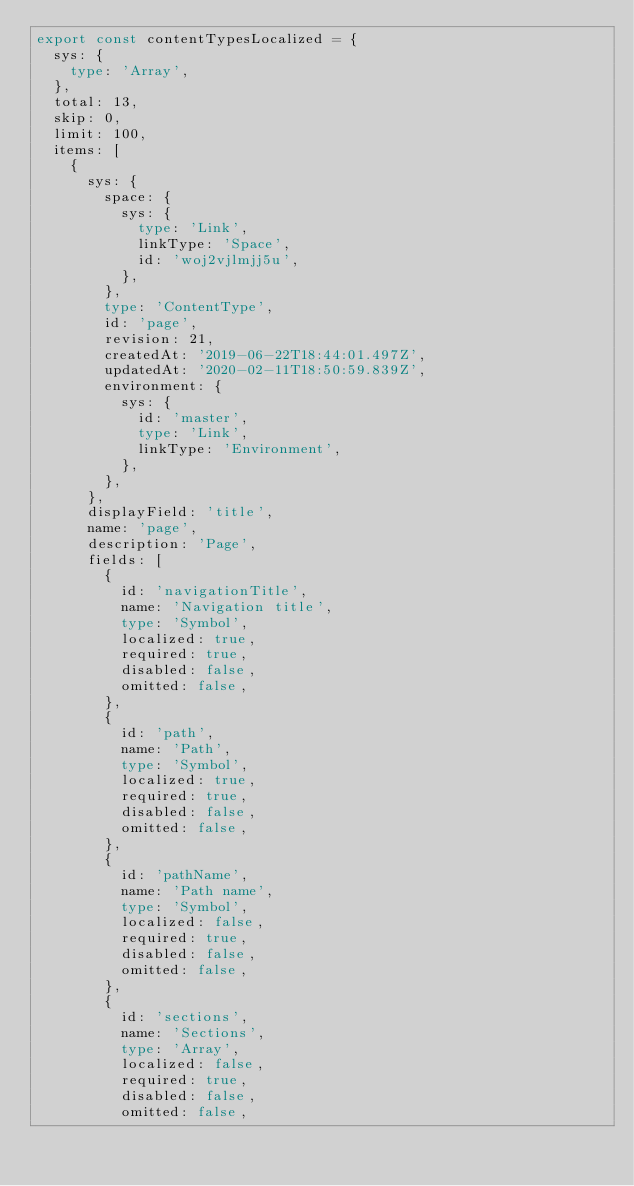Convert code to text. <code><loc_0><loc_0><loc_500><loc_500><_TypeScript_>export const contentTypesLocalized = {
  sys: {
    type: 'Array',
  },
  total: 13,
  skip: 0,
  limit: 100,
  items: [
    {
      sys: {
        space: {
          sys: {
            type: 'Link',
            linkType: 'Space',
            id: 'woj2vjlmjj5u',
          },
        },
        type: 'ContentType',
        id: 'page',
        revision: 21,
        createdAt: '2019-06-22T18:44:01.497Z',
        updatedAt: '2020-02-11T18:50:59.839Z',
        environment: {
          sys: {
            id: 'master',
            type: 'Link',
            linkType: 'Environment',
          },
        },
      },
      displayField: 'title',
      name: 'page',
      description: 'Page',
      fields: [
        {
          id: 'navigationTitle',
          name: 'Navigation title',
          type: 'Symbol',
          localized: true,
          required: true,
          disabled: false,
          omitted: false,
        },
        {
          id: 'path',
          name: 'Path',
          type: 'Symbol',
          localized: true,
          required: true,
          disabled: false,
          omitted: false,
        },
        {
          id: 'pathName',
          name: 'Path name',
          type: 'Symbol',
          localized: false,
          required: true,
          disabled: false,
          omitted: false,
        },
        {
          id: 'sections',
          name: 'Sections',
          type: 'Array',
          localized: false,
          required: true,
          disabled: false,
          omitted: false,</code> 